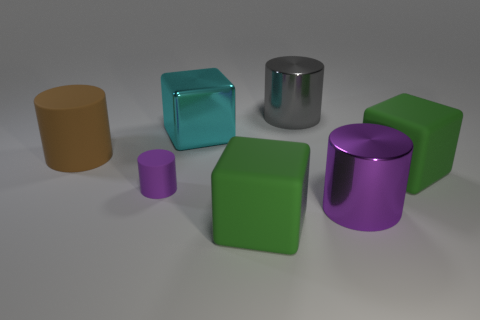There is a rubber cylinder in front of the object to the left of the small purple matte cylinder; is there a gray metallic cylinder behind it?
Provide a succinct answer. Yes. The cylinder that is made of the same material as the big purple thing is what color?
Give a very brief answer. Gray. How many cyan blocks are the same material as the cyan thing?
Offer a very short reply. 0. Does the big gray cylinder have the same material as the large green block behind the purple metallic cylinder?
Give a very brief answer. No. What number of objects are big green matte blocks that are left of the gray metallic cylinder or big metal cylinders?
Offer a terse response. 3. There is a metallic object that is in front of the big brown matte cylinder in front of the big cyan thing in front of the gray metallic thing; what is its size?
Offer a very short reply. Large. Is there anything else that has the same shape as the small matte object?
Give a very brief answer. Yes. How big is the green matte cube in front of the green matte thing behind the small cylinder?
Provide a short and direct response. Large. What number of large objects are metal cubes or green matte things?
Provide a succinct answer. 3. Are there fewer brown cylinders than red cylinders?
Your answer should be very brief. No. 